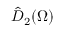Convert formula to latex. <formula><loc_0><loc_0><loc_500><loc_500>\hat { D } _ { 2 } ( \Omega )</formula> 